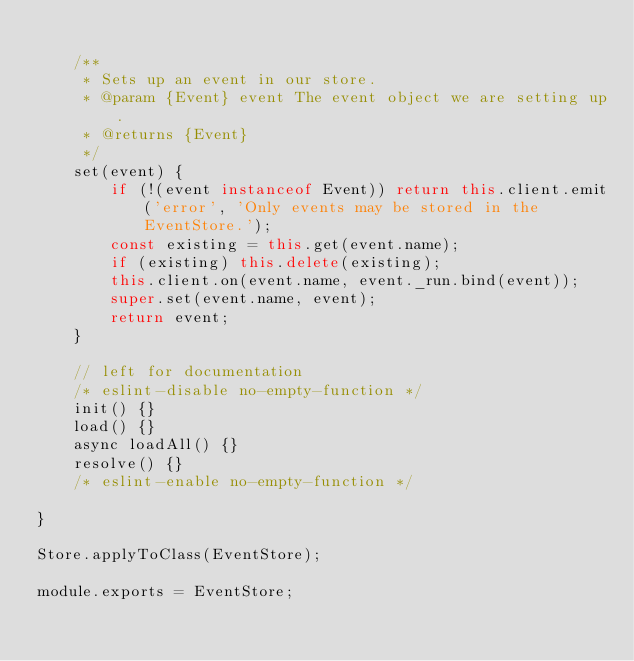<code> <loc_0><loc_0><loc_500><loc_500><_JavaScript_>
	/**
	 * Sets up an event in our store.
	 * @param {Event} event The event object we are setting up.
	 * @returns {Event}
	 */
	set(event) {
		if (!(event instanceof Event)) return this.client.emit('error', 'Only events may be stored in the EventStore.');
		const existing = this.get(event.name);
		if (existing) this.delete(existing);
		this.client.on(event.name, event._run.bind(event));
		super.set(event.name, event);
		return event;
	}

	// left for documentation
	/* eslint-disable no-empty-function */
	init() {}
	load() {}
	async loadAll() {}
	resolve() {}
	/* eslint-enable no-empty-function */

}

Store.applyToClass(EventStore);

module.exports = EventStore;
</code> 